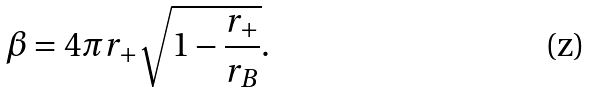<formula> <loc_0><loc_0><loc_500><loc_500>\beta = 4 \pi r _ { + } \sqrt { 1 - \frac { r _ { + } } { r _ { B } } } \text {.}</formula> 